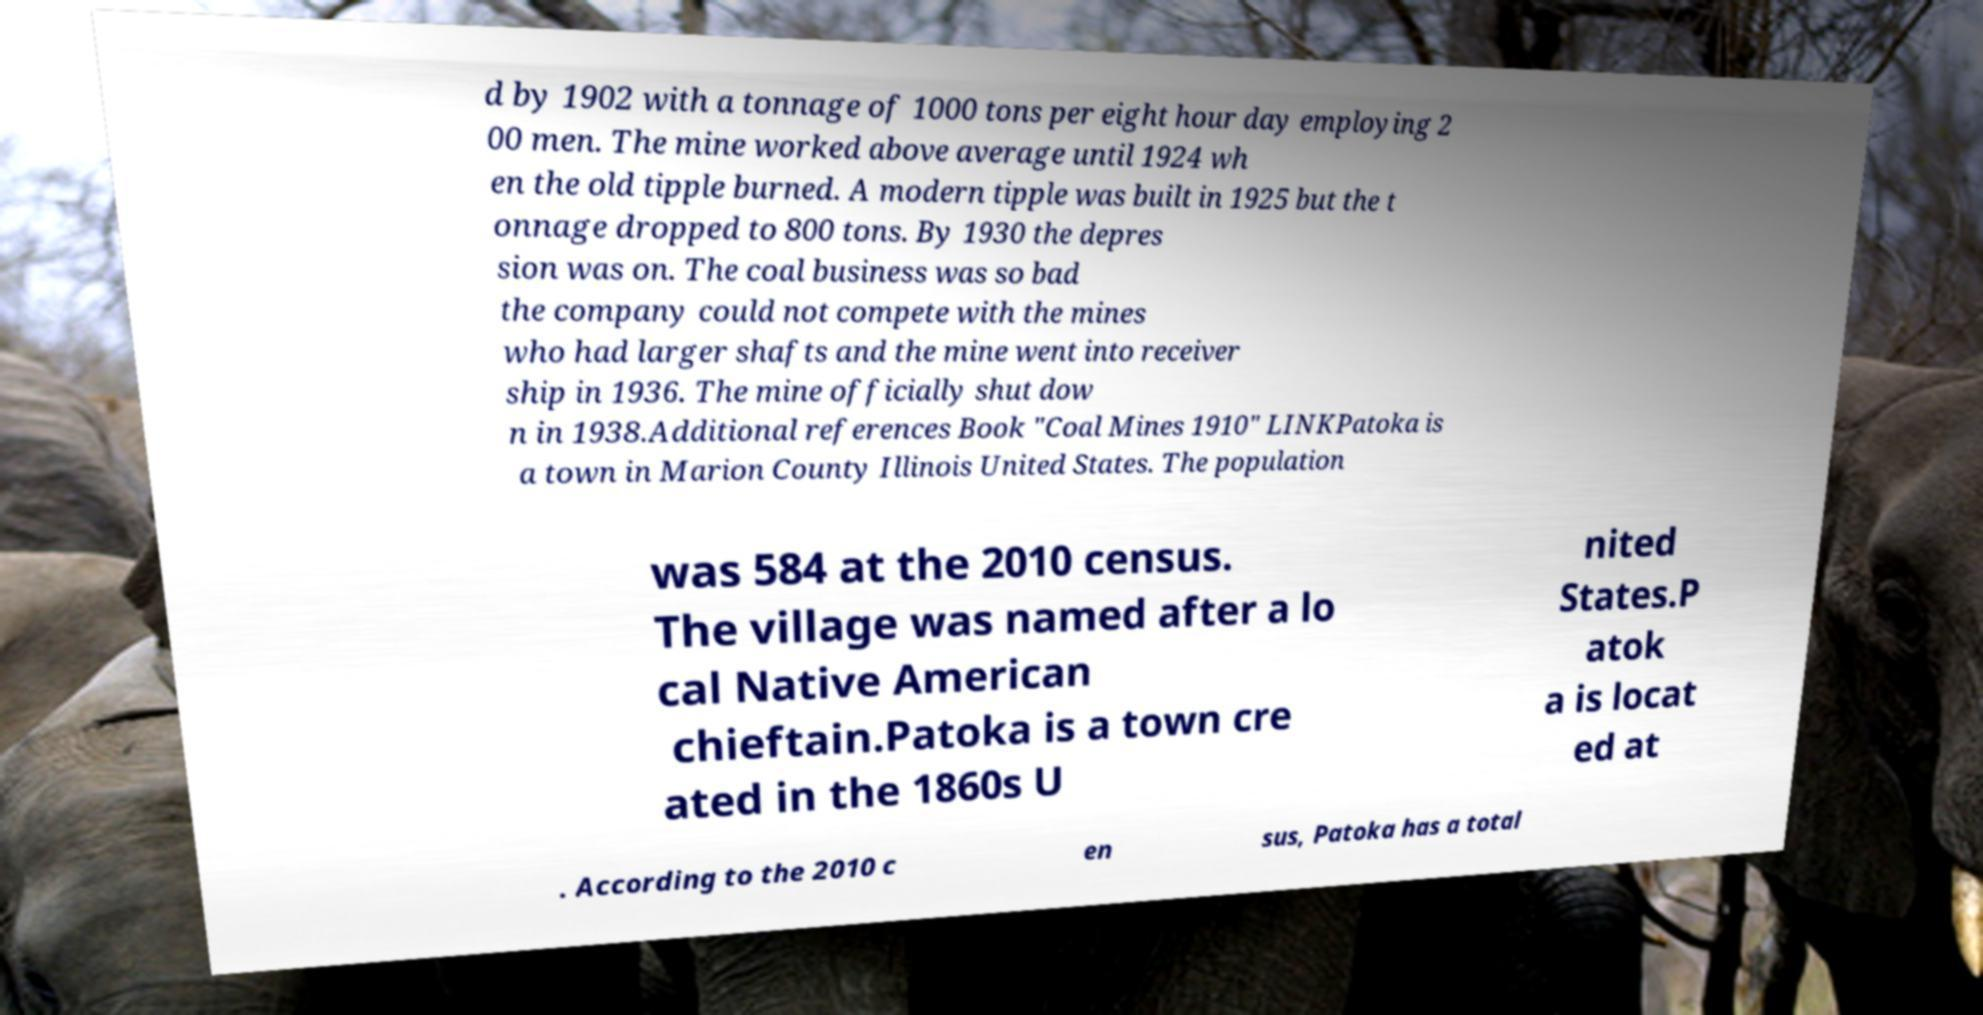Please identify and transcribe the text found in this image. d by 1902 with a tonnage of 1000 tons per eight hour day employing 2 00 men. The mine worked above average until 1924 wh en the old tipple burned. A modern tipple was built in 1925 but the t onnage dropped to 800 tons. By 1930 the depres sion was on. The coal business was so bad the company could not compete with the mines who had larger shafts and the mine went into receiver ship in 1936. The mine officially shut dow n in 1938.Additional references Book "Coal Mines 1910" LINKPatoka is a town in Marion County Illinois United States. The population was 584 at the 2010 census. The village was named after a lo cal Native American chieftain.Patoka is a town cre ated in the 1860s U nited States.P atok a is locat ed at . According to the 2010 c en sus, Patoka has a total 